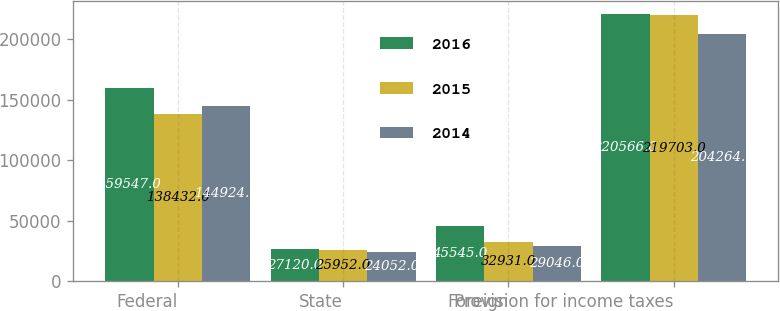Convert chart. <chart><loc_0><loc_0><loc_500><loc_500><stacked_bar_chart><ecel><fcel>Federal<fcel>State<fcel>Foreign<fcel>Provision for income taxes<nl><fcel>2016<fcel>159547<fcel>27120<fcel>45545<fcel>220566<nl><fcel>2015<fcel>138432<fcel>25952<fcel>32931<fcel>219703<nl><fcel>2014<fcel>144924<fcel>24052<fcel>29046<fcel>204264<nl></chart> 